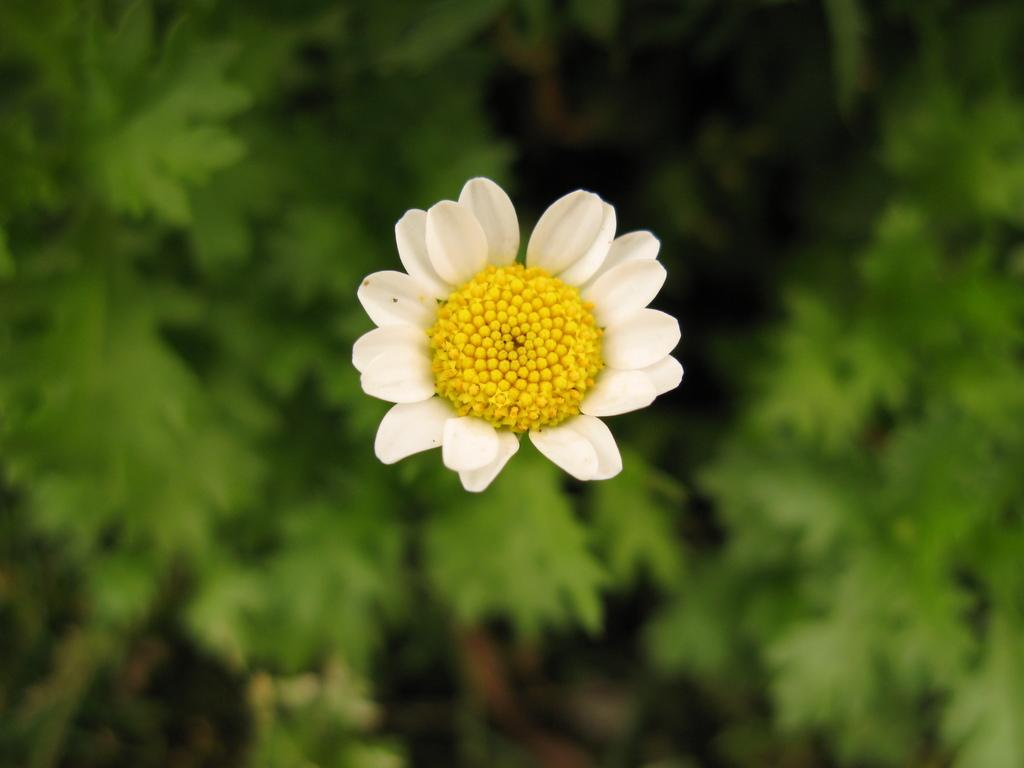What is the main subject of the image? There is a flower in the image. How would you describe the background of the image? The background of the image is blurred. Can you identify any other elements in the image besides the flower? Yes, there are plants visible in the background of the image. What type of liquid is being poured from the flower in the image? There is no liquid being poured from the flower in the image; it is a static image of a flower. Can you describe the collar of the flower in the image? There is no collar present on the flower in the image. 